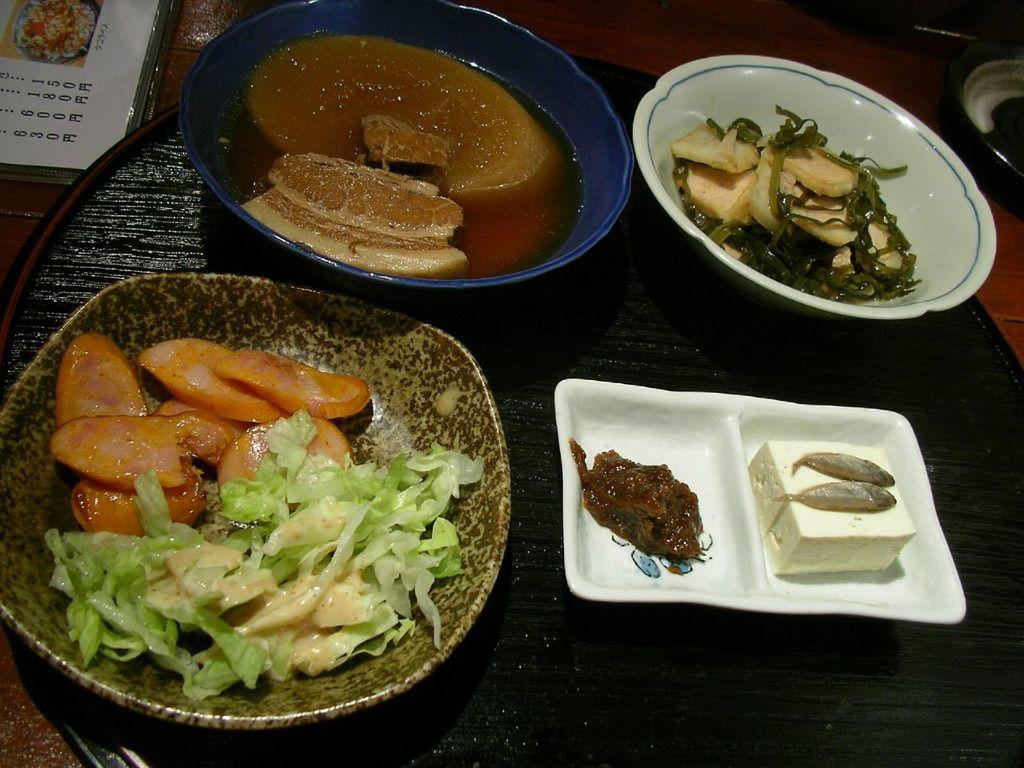What is in the bowls that are visible in the image? There are bowls with fish in the image. What type of food items are in the bowls? There are food items in the bowls. What can be seen in the background of the image? There is a paper and other objects in the background of the image. What type of surface is visible in the image? The wooden surface is visible in the image. What type of egg is being used to cover the suit in the image? There is no egg or suit present in the image; it only features bowls with fish, food items, a paper, and objects in the background on a wooden surface. 